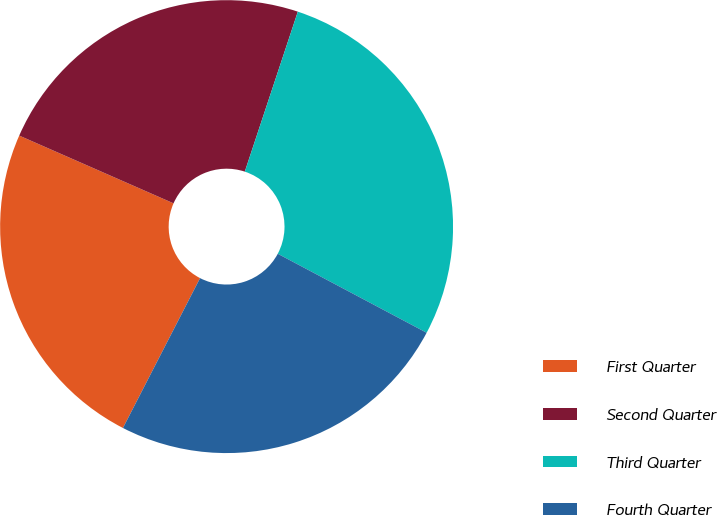<chart> <loc_0><loc_0><loc_500><loc_500><pie_chart><fcel>First Quarter<fcel>Second Quarter<fcel>Third Quarter<fcel>Fourth Quarter<nl><fcel>24.02%<fcel>23.51%<fcel>27.67%<fcel>24.8%<nl></chart> 